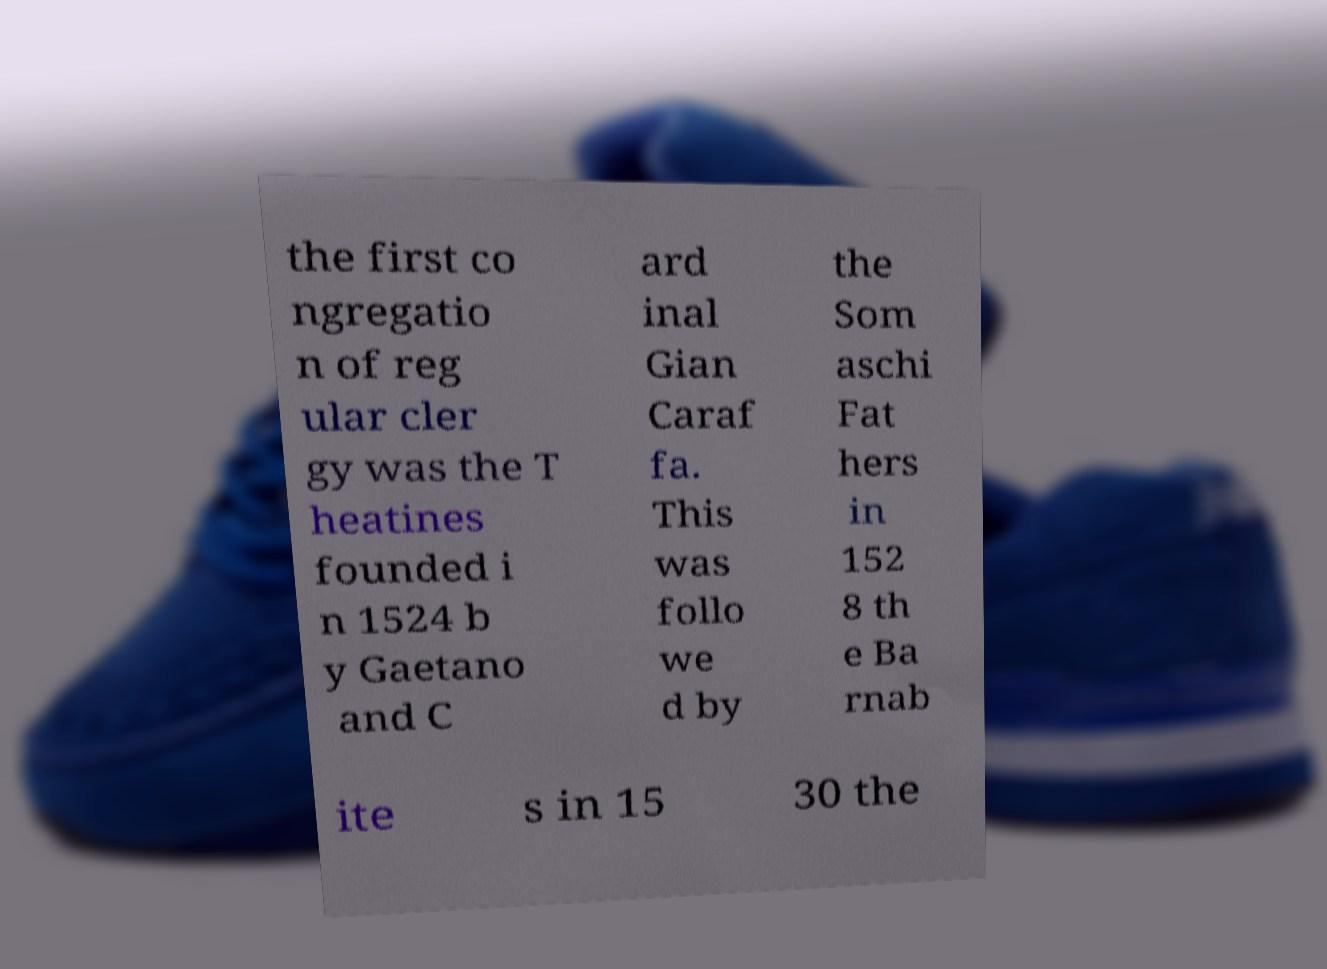Can you accurately transcribe the text from the provided image for me? the first co ngregatio n of reg ular cler gy was the T heatines founded i n 1524 b y Gaetano and C ard inal Gian Caraf fa. This was follo we d by the Som aschi Fat hers in 152 8 th e Ba rnab ite s in 15 30 the 